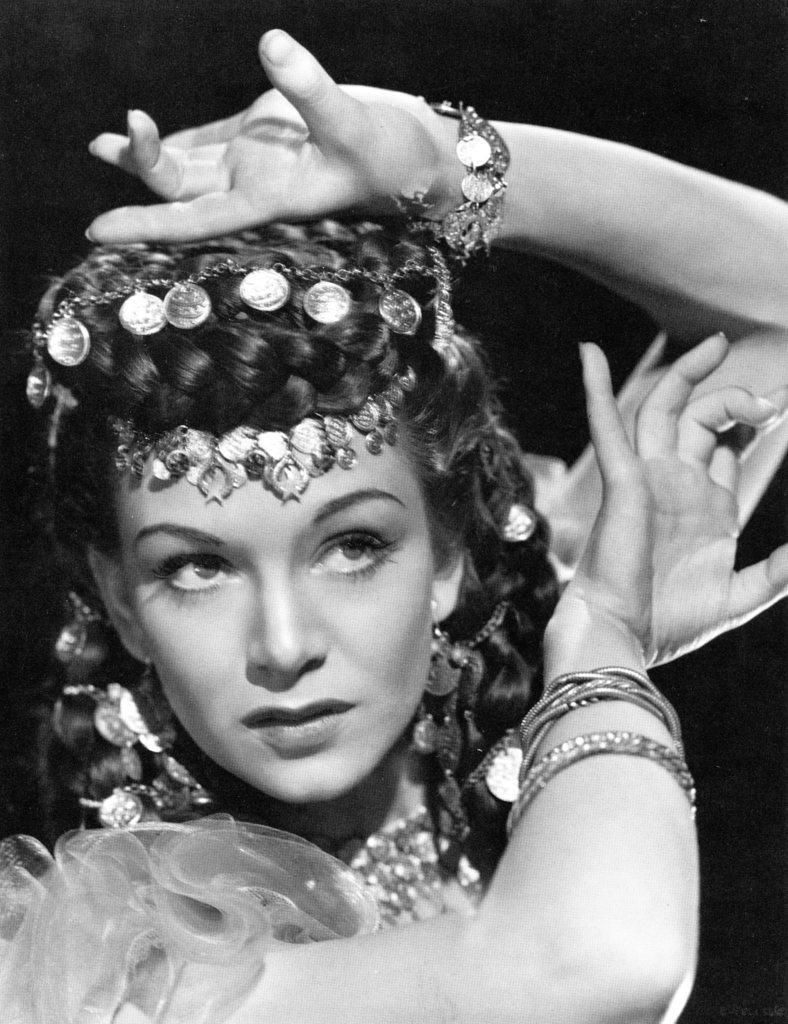Describe this image in one or two sentences. In this picture we can see a woman and in the background we can see it is dark. 